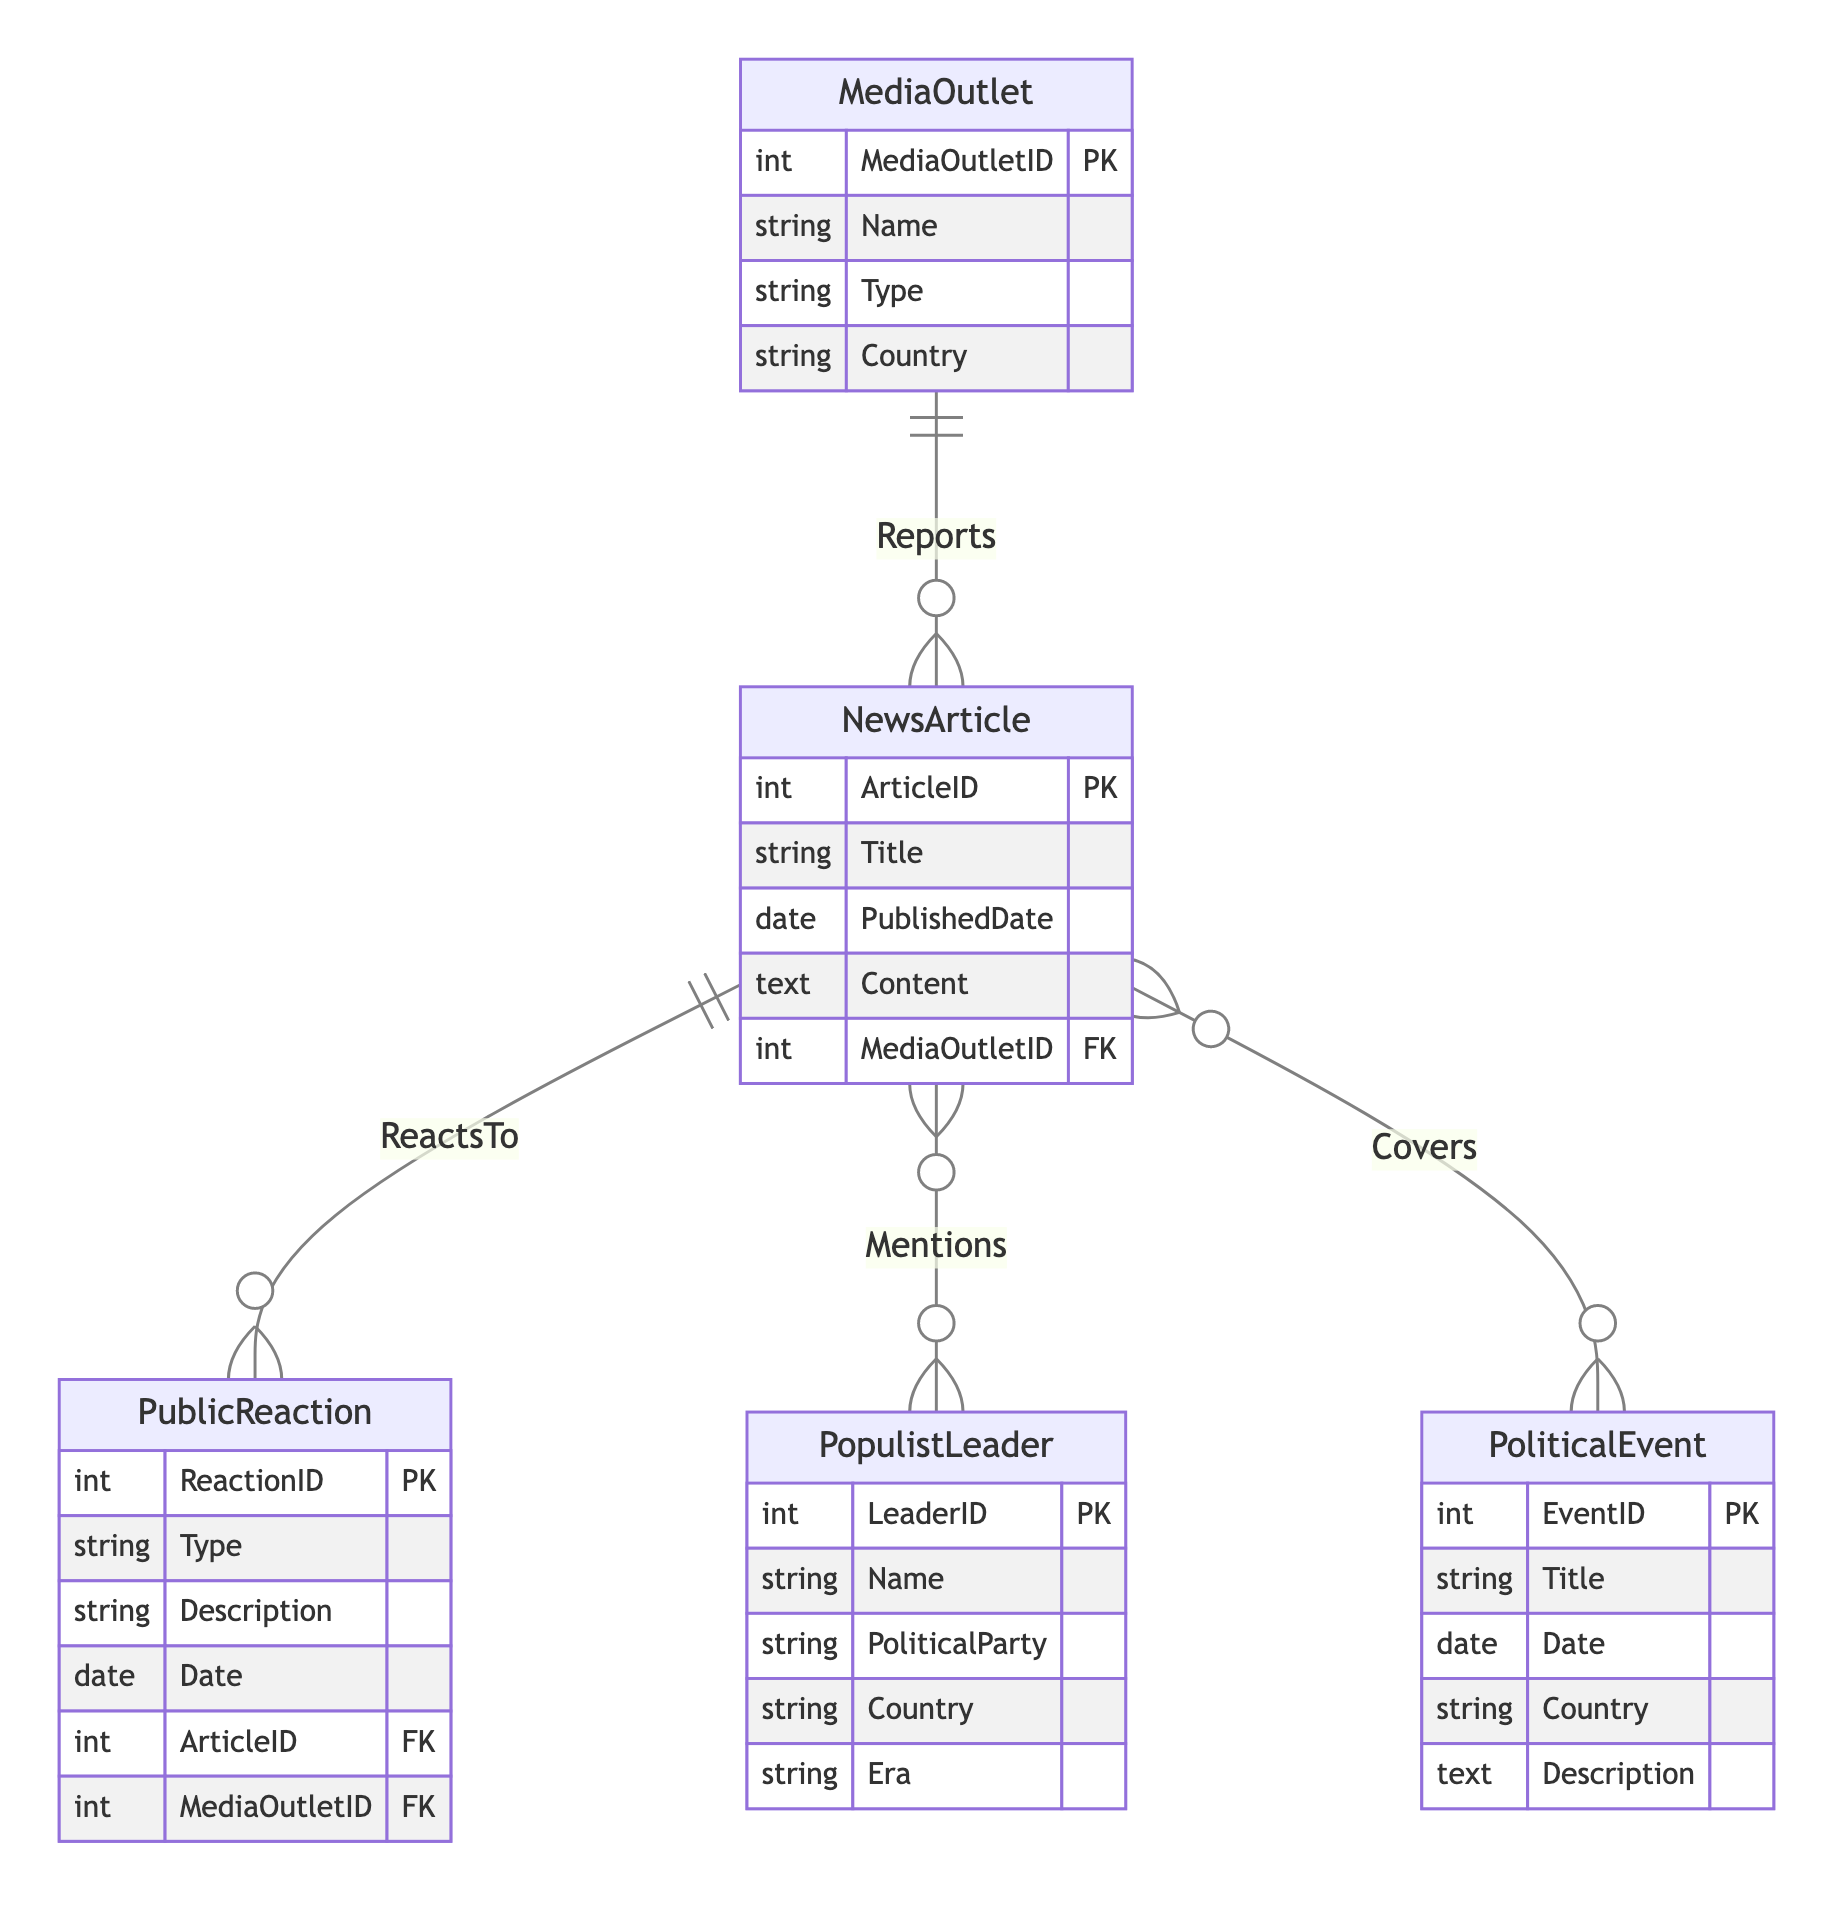What are the attributes of Populist Leader? The attributes of the Populist Leader in the diagram are LeaderID, Name, PoliticalParty, Country, and Era. These attributes define the characteristics of the Populist Leader entity.
Answer: LeaderID, Name, PoliticalParty, Country, Era How many relationships are there in the diagram? The diagram contains four relationships: Reports, ReactsTo, Mentions, and Covers. Each one connects different entities and reflects interactions among them.
Answer: 4 Which entity is responsible for reporting News Articles? The Media Outlet entity is responsible for reporting News Articles, as indicated by the "Reports" relationship linking Media Outlet to News Article.
Answer: Media Outlet What entity is mentioned in News Articles? The Populist Leader entity is mentioned in News Articles, as shown by the "Mentions" relationship connecting News Article to Populist Leader.
Answer: Populist Leader How many attributes does the Public Reaction entity have? The Public Reaction entity has five attributes: ReactionID, Type, Description, Date, ArticleID, and MediaOutletID. This reflects the stored information regarding public responses.
Answer: 5 What comes first in the reporting chain: Media Outlet or News Article? Media Outlet comes first in the reporting chain because it is the source that reports the News Article through the "Reports" relationship shown in the diagram.
Answer: Media Outlet Which entity is linked to the Political Event through News Articles? The News Article entity is linked to the Political Event through the "Covers" relationship, indicating that News Articles provide coverage on Political Events.
Answer: News Article What type of entity is Government Media classified as? Government Media is classified under the Type attribute within the Media Outlet entity, which includes different types of media entities indicated in the diagram.
Answer: Government Media What describes the nature of the Public Reaction? The Public Reaction can encompass various Types such as positive, negative, or neutral responses to articles, as defined in the attributes of the Public Reaction entity.
Answer: Various Types 